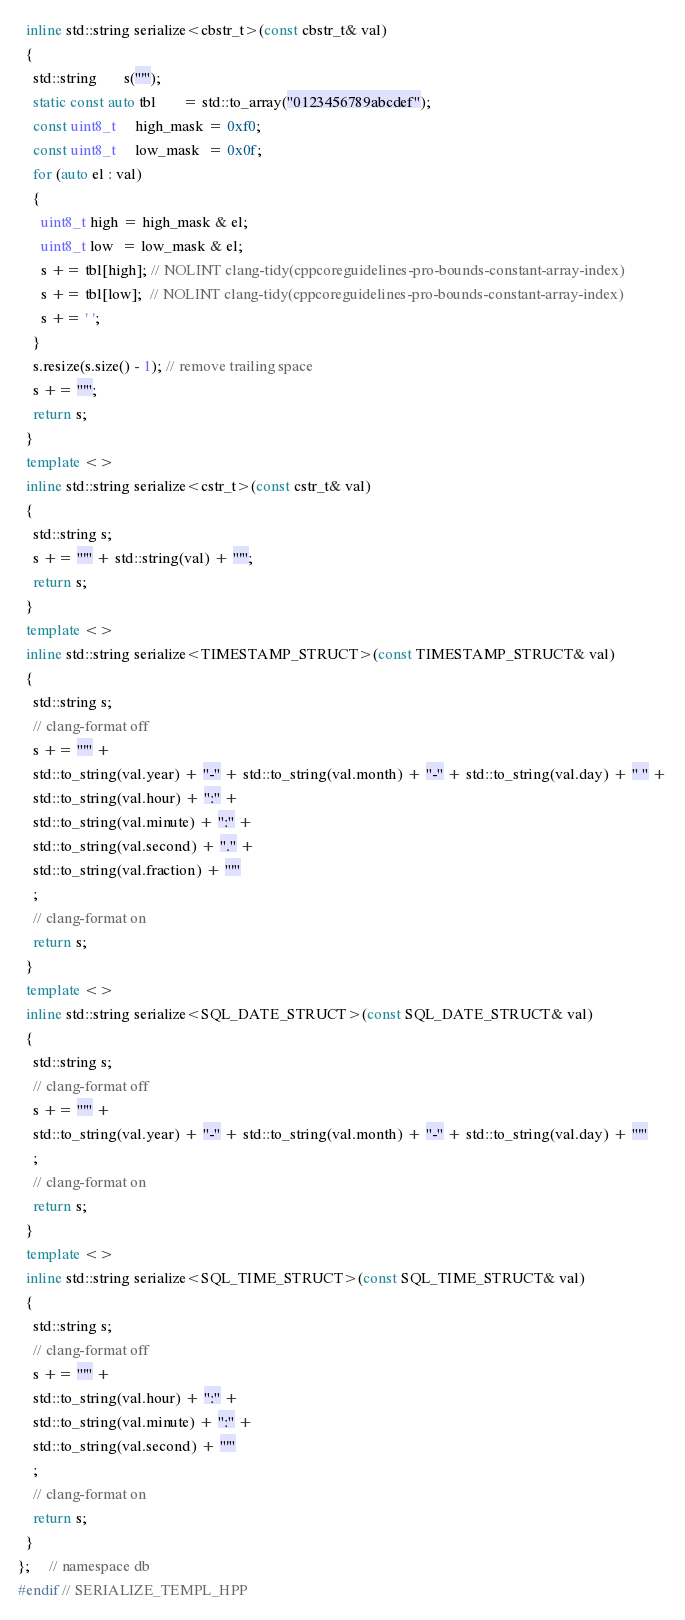<code> <loc_0><loc_0><loc_500><loc_500><_C++_>  inline std::string serialize<cbstr_t>(const cbstr_t& val)
  {
    std::string       s("'");
    static const auto tbl       = std::to_array("0123456789abcdef");
    const uint8_t     high_mask = 0xf0;
    const uint8_t     low_mask  = 0x0f;
    for (auto el : val)
    {
      uint8_t high = high_mask & el;
      uint8_t low  = low_mask & el;
      s += tbl[high]; // NOLINT clang-tidy(cppcoreguidelines-pro-bounds-constant-array-index)
      s += tbl[low];  // NOLINT clang-tidy(cppcoreguidelines-pro-bounds-constant-array-index)
      s += ' ';
    }
    s.resize(s.size() - 1); // remove trailing space
    s += "'";
    return s;
  }
  template <>
  inline std::string serialize<cstr_t>(const cstr_t& val)
  {
    std::string s;
    s += "'" + std::string(val) + "'";
    return s;
  }
  template <>
  inline std::string serialize<TIMESTAMP_STRUCT>(const TIMESTAMP_STRUCT& val)
  {
    std::string s;
    // clang-format off
    s += "'" +
    std::to_string(val.year) + "-" + std::to_string(val.month) + "-" + std::to_string(val.day) + " " +
    std::to_string(val.hour) + ":" +
    std::to_string(val.minute) + ":" +
    std::to_string(val.second) + "." +
    std::to_string(val.fraction) + "'"
    ;
    // clang-format on
    return s;
  }
  template <>
  inline std::string serialize<SQL_DATE_STRUCT>(const SQL_DATE_STRUCT& val)
  {
    std::string s;
    // clang-format off
    s += "'" +
    std::to_string(val.year) + "-" + std::to_string(val.month) + "-" + std::to_string(val.day) + "'"
    ;
    // clang-format on
    return s;
  }
  template <>
  inline std::string serialize<SQL_TIME_STRUCT>(const SQL_TIME_STRUCT& val)
  {
    std::string s;
    // clang-format off
    s += "'" +
    std::to_string(val.hour) + ":" +
    std::to_string(val.minute) + ":" +
    std::to_string(val.second) + "'"
    ;
    // clang-format on
    return s;
  }
};     // namespace db
#endif // SERIALIZE_TEMPL_HPP
</code> 